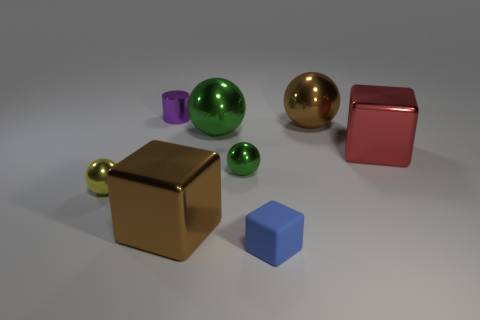Subtract all green cylinders. How many green balls are left? 2 Subtract all yellow shiny spheres. How many spheres are left? 3 Add 2 shiny blocks. How many objects exist? 10 Subtract all cylinders. How many objects are left? 7 Subtract all purple balls. Subtract all purple cubes. How many balls are left? 4 Subtract all brown metal objects. Subtract all metallic blocks. How many objects are left? 4 Add 1 brown metallic balls. How many brown metallic balls are left? 2 Add 8 brown spheres. How many brown spheres exist? 9 Subtract 2 green spheres. How many objects are left? 6 